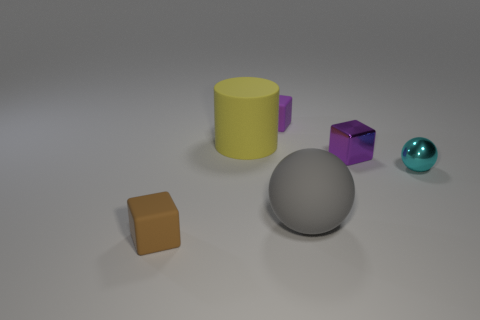Subtract all purple metallic cubes. How many cubes are left? 2 Add 1 tiny purple rubber balls. How many objects exist? 7 Subtract all gray balls. How many balls are left? 1 Subtract all cylinders. How many objects are left? 5 Subtract 1 blocks. How many blocks are left? 2 Subtract all yellow cylinders. How many purple cubes are left? 2 Add 4 small cyan spheres. How many small cyan spheres exist? 5 Subtract 1 purple cubes. How many objects are left? 5 Subtract all red cubes. Subtract all red cylinders. How many cubes are left? 3 Subtract all tiny blue blocks. Subtract all gray objects. How many objects are left? 5 